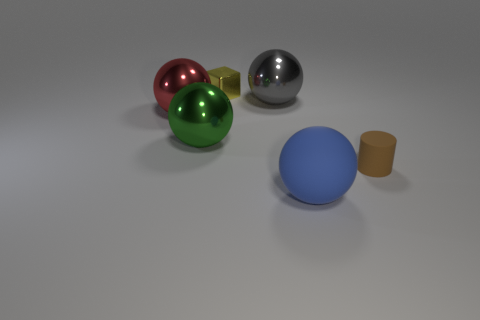What is the material of the large red thing behind the large ball that is in front of the big green sphere? The large red object behind the blue ball and in front of the green sphere appears to be a glossy, metallic surface, likely aluminum or a similar metal, often used in decorative objects or potentially functional items like furniture. 